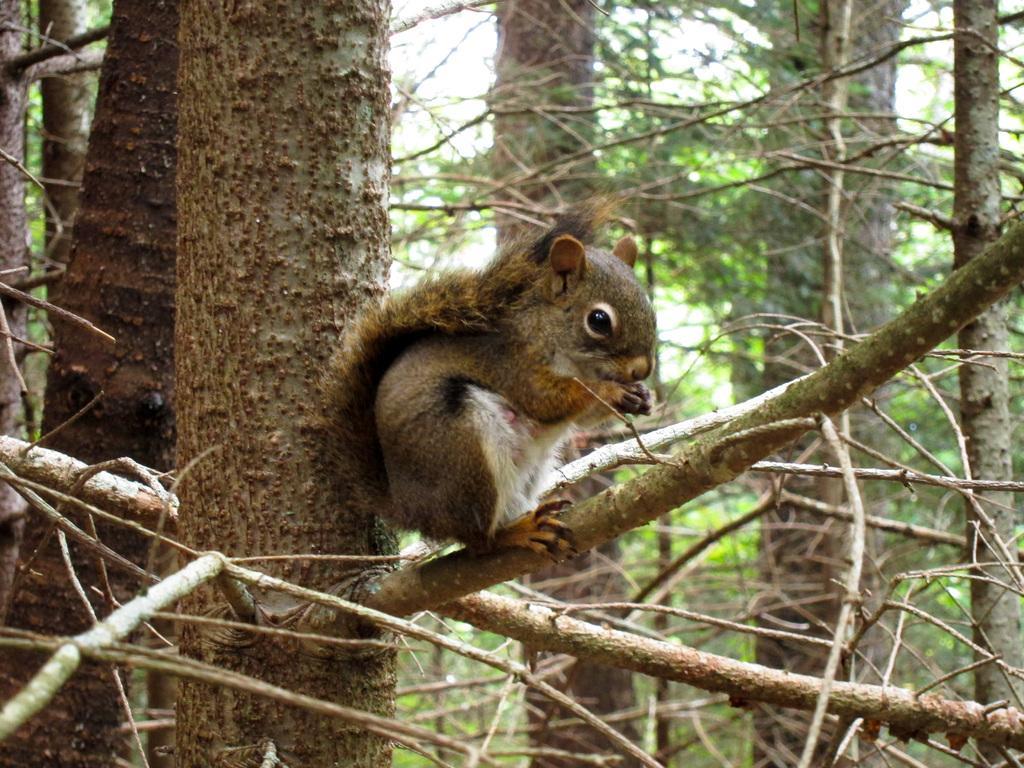Please provide a concise description of this image. This image consists of a tree and there is a squirrel in the middle. 